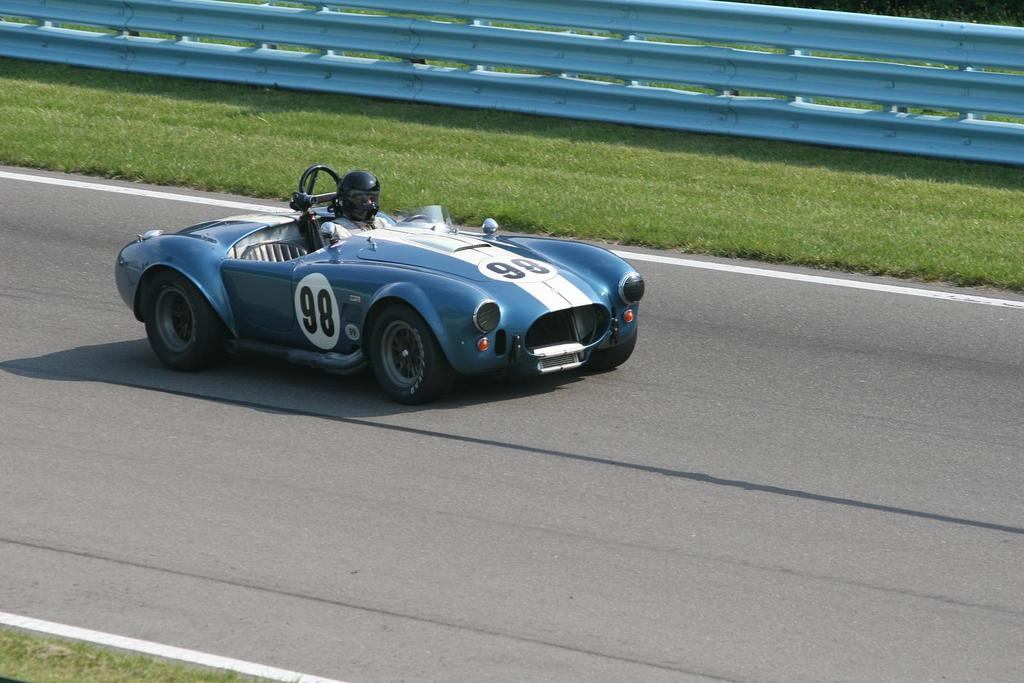What is the main subject of the image? The main subject of the image is a car on the road. Can you describe the car's occupant? There is a person in the car. What type of vegetation can be seen on both sides of the road? Grass is visible on both sides of the road. What is the purpose of the railing at the top of the image? The railing at the top of the image is likely for safety or to prevent vehicles from going off the road. What type of bead is being used to decorate the sea in the image? There is no sea or bead present in the image; it features a car on the road with grass on both sides and a railing at the top. What type of crime is being committed in the image? There is no crime being committed in the image; it features a car on the road with a person inside, grass on both sides, and a railing at the top. 